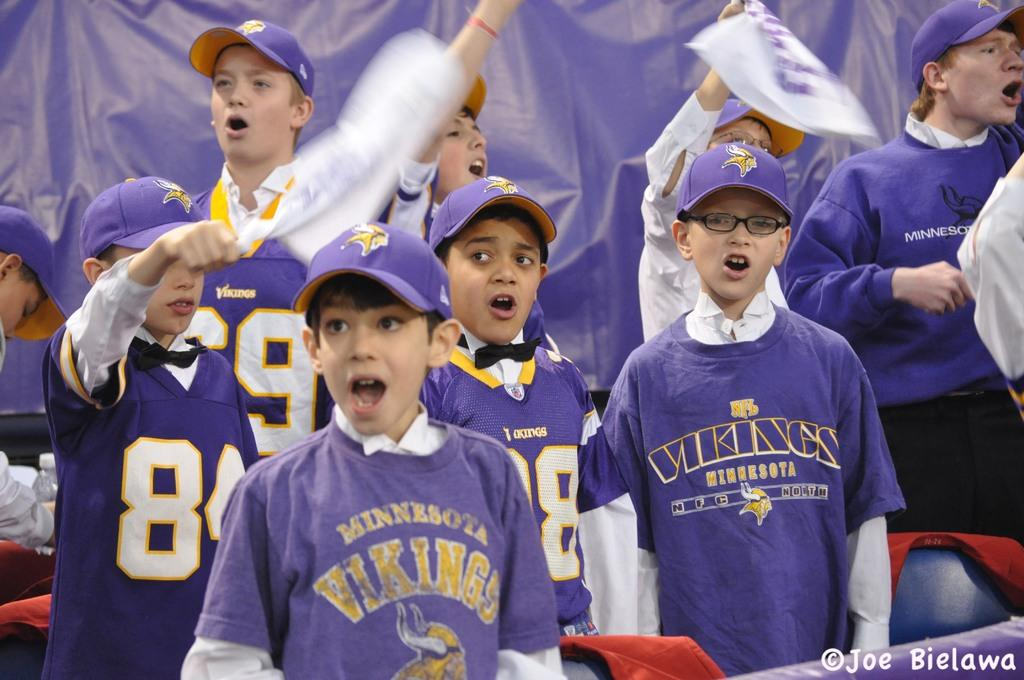Provide a one-sentence caption for the provided image. Several young boys wearing purple Minnesota Vikings tops support their team. 